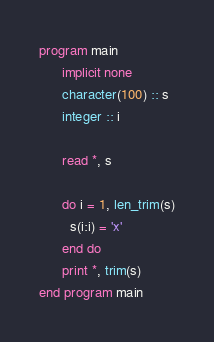<code> <loc_0><loc_0><loc_500><loc_500><_FORTRAN_>program main
      implicit none
      character(100) :: s
      integer :: i

      read *, s
      
      do i = 1, len_trim(s)
        s(i:i) = 'x'
      end do
      print *, trim(s)
end program main
</code> 